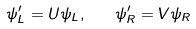<formula> <loc_0><loc_0><loc_500><loc_500>\psi _ { L } ^ { \prime } = U \psi _ { L } , \quad \psi _ { R } ^ { \prime } = V \psi _ { R }</formula> 